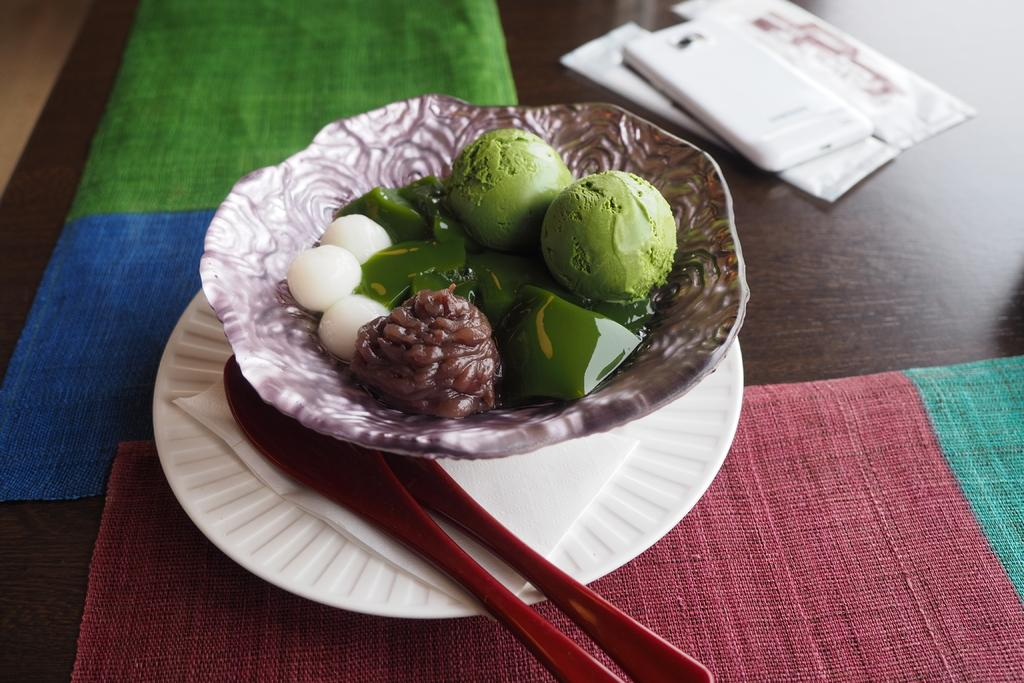What is in the bowl that is visible in the image? There is a bowl with ice cream in the image. Besides ice cream, what other items can be seen in the image? There are sweets and plastic spoons visible in the image. Where is the mobile located in the image? The mobile is on the table in the image. What might be used for cleaning or wiping in the image? Napkins are present in the image for cleaning or wiping. What type of pet can be seen interacting with the ice cream in the image? There is no pet present in the image; it only features a bowl of ice cream, sweets, plastic spoons, a mobile, and napkins. 